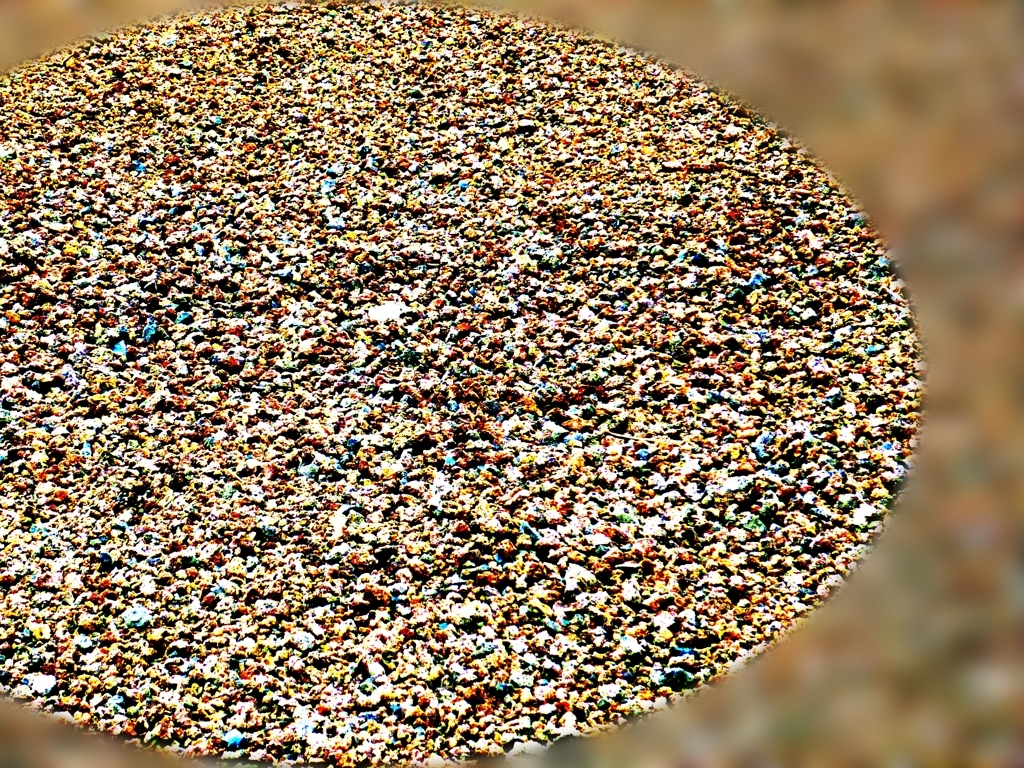Is there noticeable noise present in the image?
A. No
B. Yes
Answer with the option's letter from the given choices directly.
 B. 